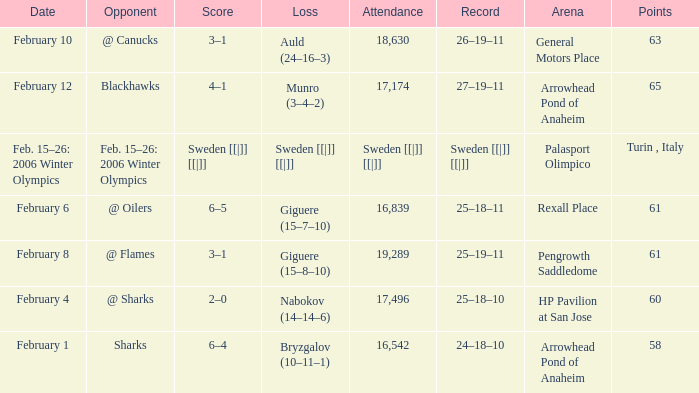What were the points on February 10? 63.0. 